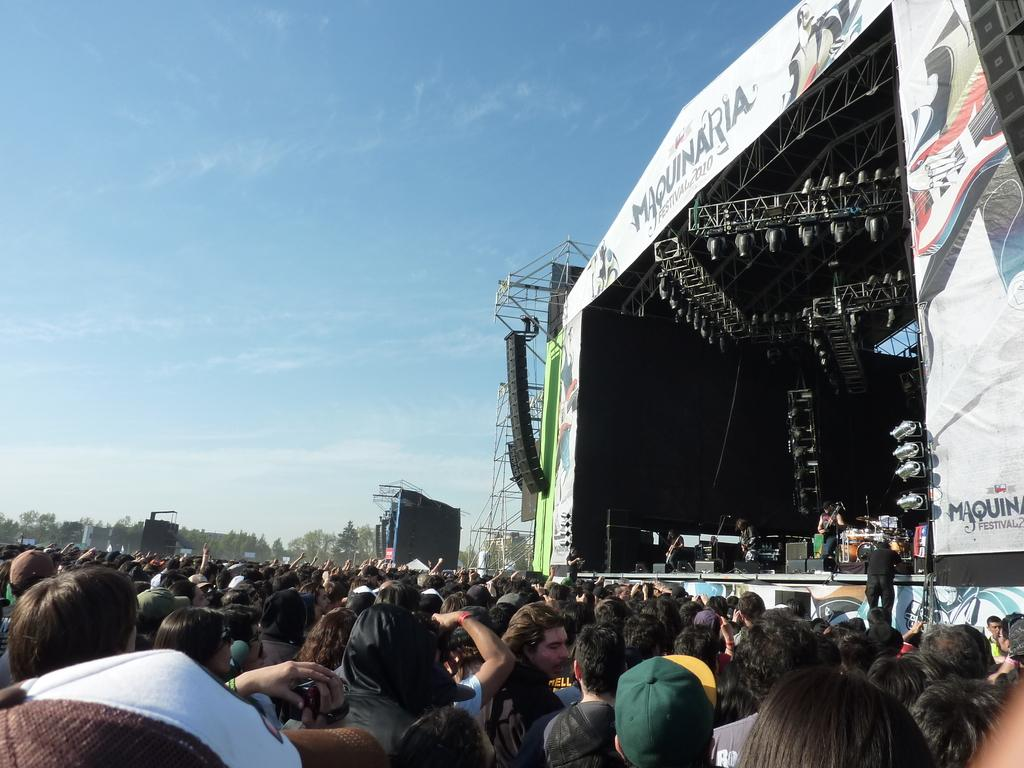What are the people in the image doing? The people in the image are standing on the ground and on a dais. What type of lighting is present in the image? Electric lights are present in the image. What type of structure can be seen in the image? Iron grills are visible in the image. What type of natural elements are present in the image? Trees are present in the image. What are the people on the dais possibly doing? The people on the dais might be performing or giving a speech, as musical instruments are also visible in the image. What is visible in the background of the image? The sky is visible in the background of the image, with clouds present. How are the people transporting the sail in the image? There is no sail present in the image. What type of lock is visible on the iron grills in the image? There is no lock visible on the iron grills in the image. 